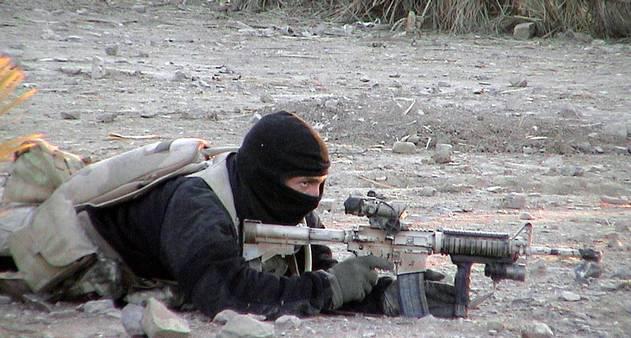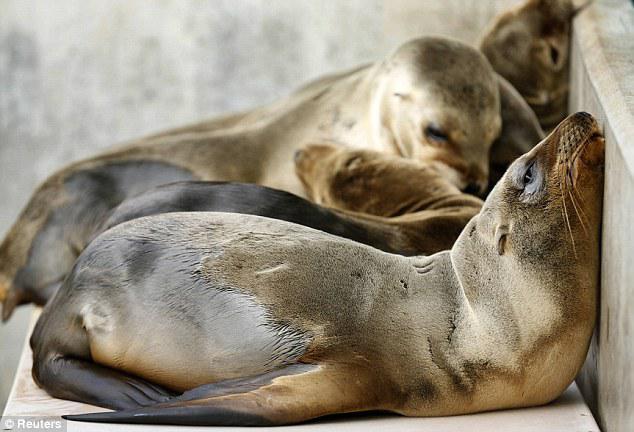The first image is the image on the left, the second image is the image on the right. Examine the images to the left and right. Is the description "The right image contains two seals." accurate? Answer yes or no. No. 